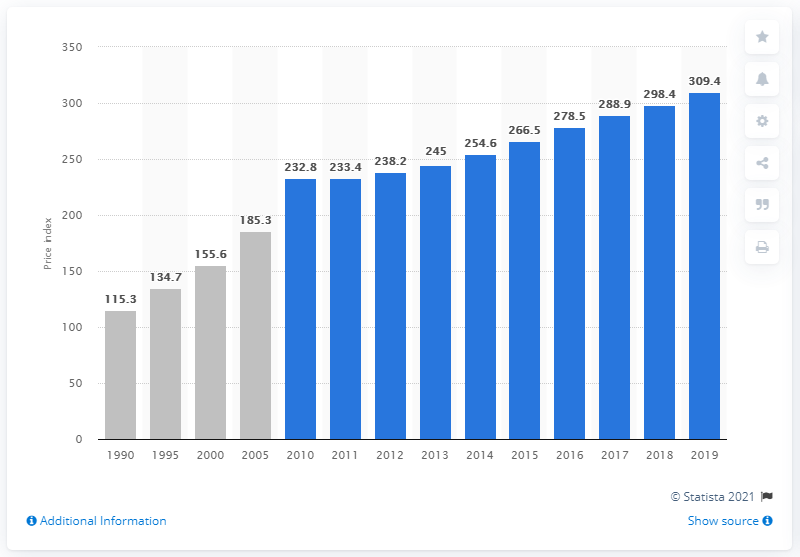Specify some key components in this picture. In 2019, the index value of concrete ingredients and related products was 309.4. 